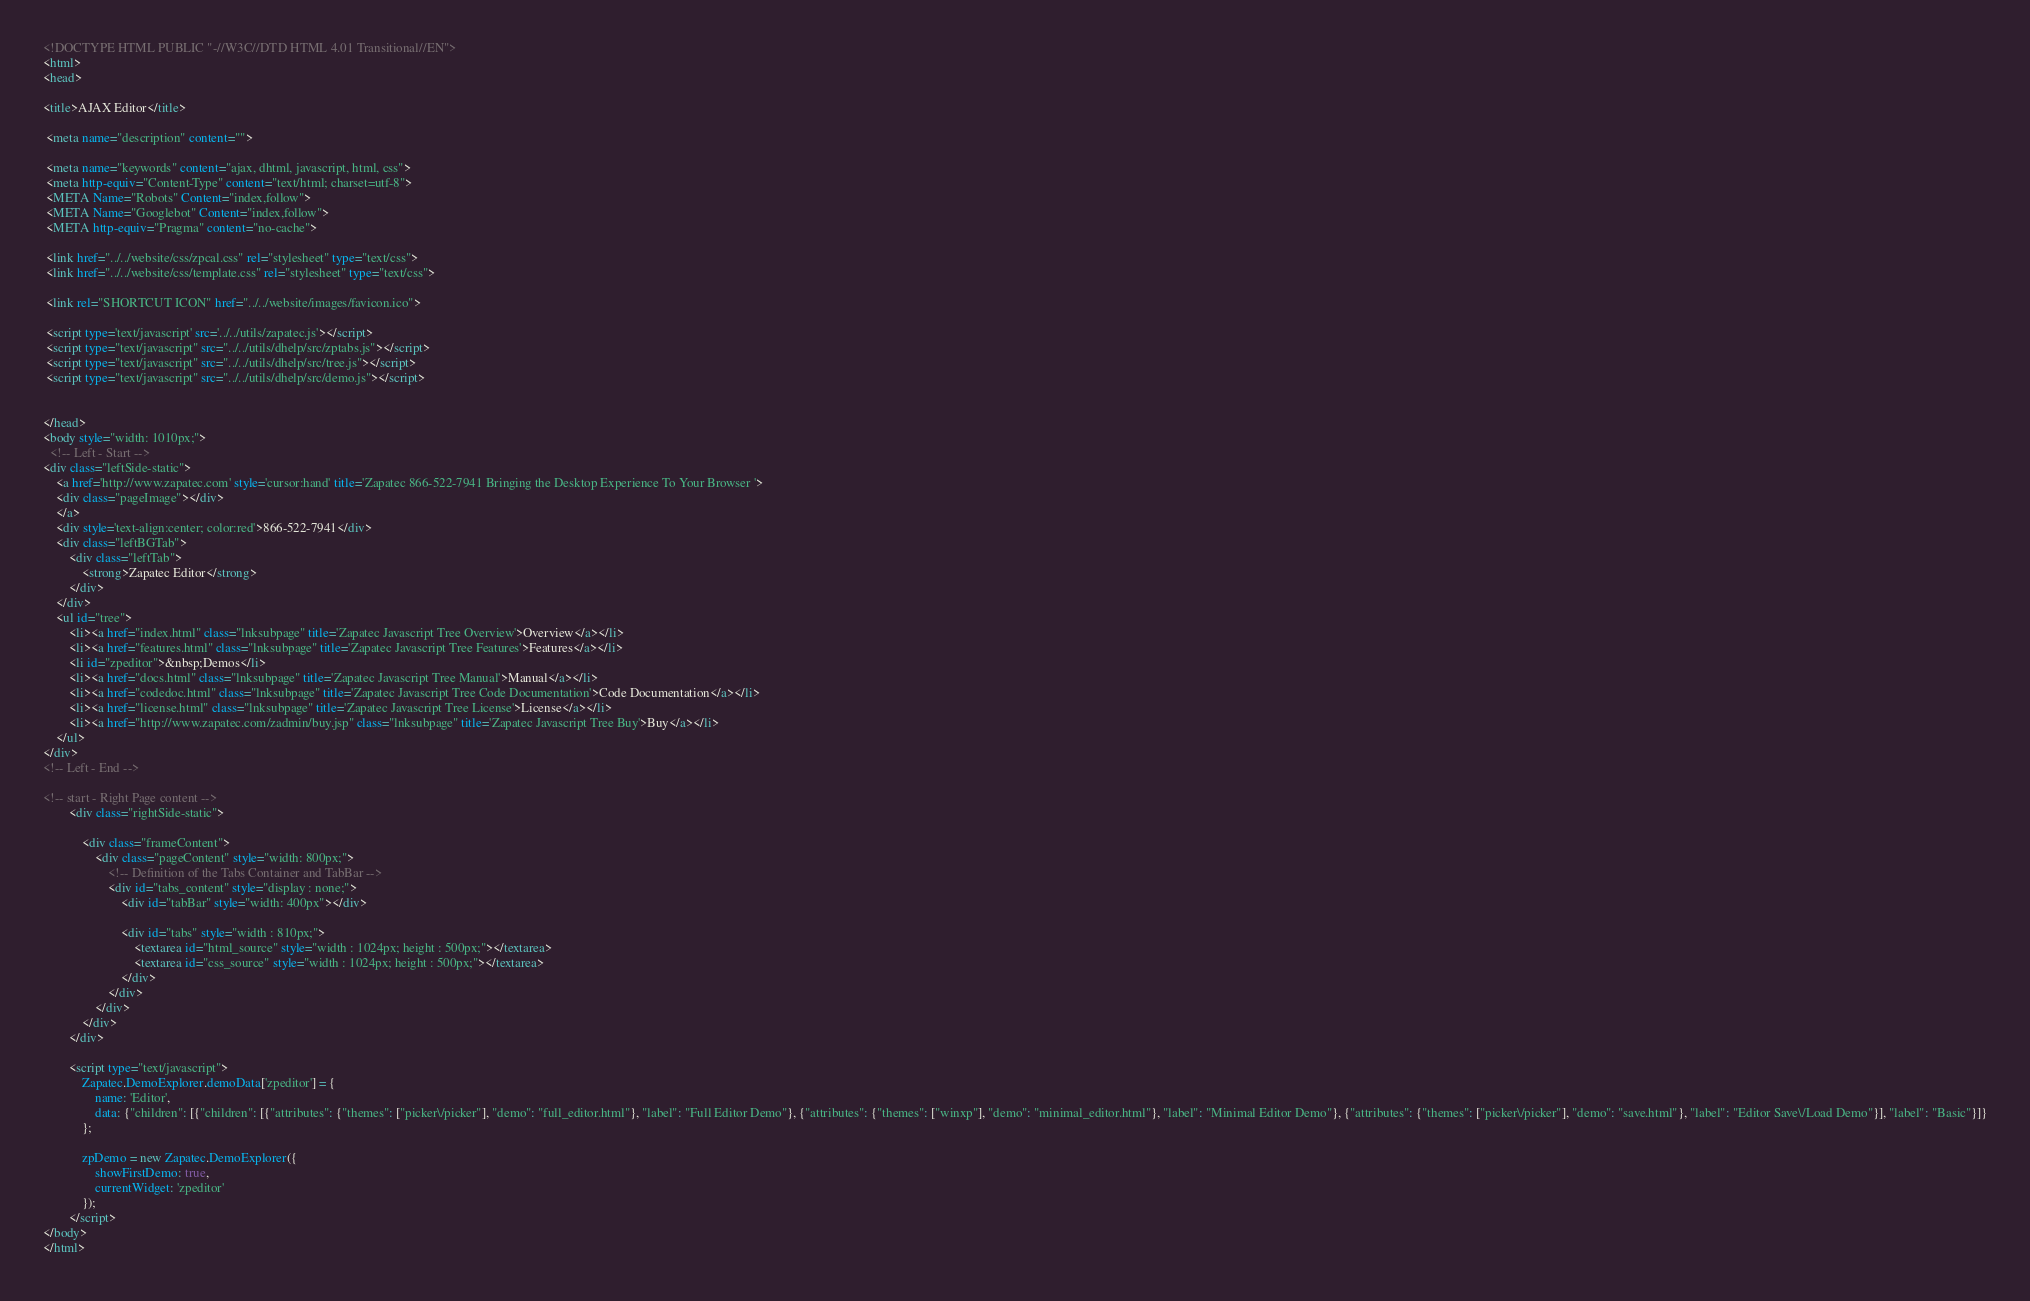<code> <loc_0><loc_0><loc_500><loc_500><_HTML_><!DOCTYPE HTML PUBLIC "-//W3C//DTD HTML 4.01 Transitional//EN">
<html>
<head>

<title>AJAX Editor</title>

 <meta name="description" content="">

 <meta name="keywords" content="ajax, dhtml, javascript, html, css">
 <meta http-equiv="Content-Type" content="text/html; charset=utf-8">
 <META Name="Robots" Content="index,follow">
 <META Name="Googlebot" Content="index,follow">
 <META http-equiv="Pragma" content="no-cache">

 <link href="../../website/css/zpcal.css" rel="stylesheet" type="text/css">
 <link href="../../website/css/template.css" rel="stylesheet" type="text/css">

 <link rel="SHORTCUT ICON" href="../../website/images/favicon.ico">

 <script type='text/javascript' src='../../utils/zapatec.js'></script>
 <script type="text/javascript" src="../../utils/dhelp/src/zptabs.js"></script>
 <script type="text/javascript" src="../../utils/dhelp/src/tree.js"></script>
 <script type="text/javascript" src="../../utils/dhelp/src/demo.js"></script>


</head>
<body style="width: 1010px;">
  <!-- Left - Start -->
<div class="leftSide-static">
 	<a href='http://www.zapatec.com' style='cursor:hand' title='Zapatec 866-522-7941 Bringing the Desktop Experience To Your Browser '>
	<div class="pageImage"></div>
	</a>
	<div style='text-align:center; color:red'>866-522-7941</div>
	<div class="leftBGTab">
		<div class="leftTab">
			<strong>Zapatec Editor</strong>
		</div>
	</div>
    <ul id="tree">
        <li><a href="index.html" class="lnksubpage" title='Zapatec Javascript Tree Overview'>Overview</a></li>
	    <li><a href="features.html" class="lnksubpage" title='Zapatec Javascript Tree Features'>Features</a></li>
	    <li id="zpeditor">&nbsp;Demos</li>
	    <li><a href="docs.html" class="lnksubpage" title='Zapatec Javascript Tree Manual'>Manual</a></li>
	    <li><a href="codedoc.html" class="lnksubpage" title='Zapatec Javascript Tree Code Documentation'>Code Documentation</a></li>
	    <li><a href="license.html" class="lnksubpage" title='Zapatec Javascript Tree License'>License</a></li>
	    <li><a href="http://www.zapatec.com/zadmin/buy.jsp" class="lnksubpage" title='Zapatec Javascript Tree Buy'>Buy</a></li>
    </ul>
</div>
<!-- Left - End -->

<!-- start - Right Page content -->
		<div class="rightSide-static">

			<div class="frameContent">
				<div class="pageContent" style="width: 800px;">
					<!-- Definition of the Tabs Container and TabBar -->
					<div id="tabs_content" style="display : none;">
						<div id="tabBar" style="width: 400px"></div>
						
						<div id="tabs" style="width : 810px;">
							<textarea id="html_source" style="width : 1024px; height : 500px;"></textarea>
							<textarea id="css_source" style="width : 1024px; height : 500px;"></textarea>
						</div>
					</div>
				</div>
			</div>
		</div>

		<script type="text/javascript">
			Zapatec.DemoExplorer.demoData['zpeditor'] = {
				name: 'Editor',
				data: {"children": [{"children": [{"attributes": {"themes": ["picker\/picker"], "demo": "full_editor.html"}, "label": "Full Editor Demo"}, {"attributes": {"themes": ["winxp"], "demo": "minimal_editor.html"}, "label": "Minimal Editor Demo"}, {"attributes": {"themes": ["picker\/picker"], "demo": "save.html"}, "label": "Editor Save\/Load Demo"}], "label": "Basic"}]}
			};

			zpDemo = new Zapatec.DemoExplorer({
				showFirstDemo: true,
				currentWidget: 'zpeditor'
			});
		</script>
</body>
</html>

</code> 